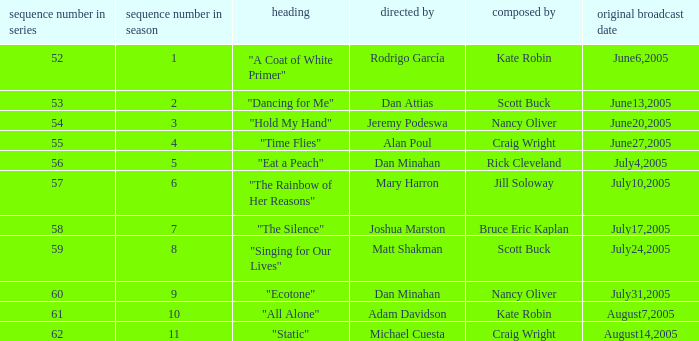What date was episode 10 in the season originally aired? August7,2005. 